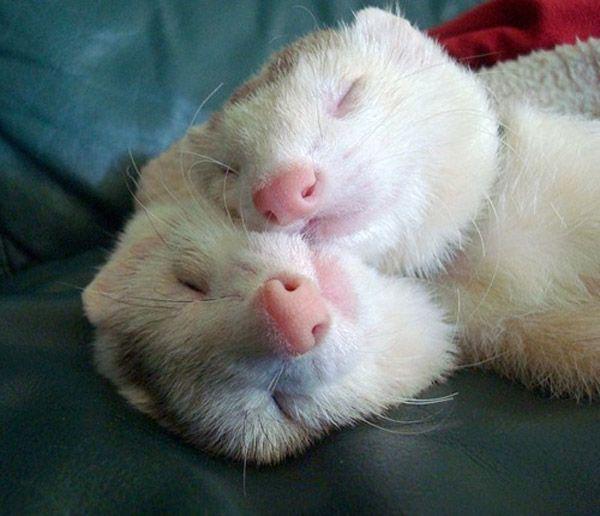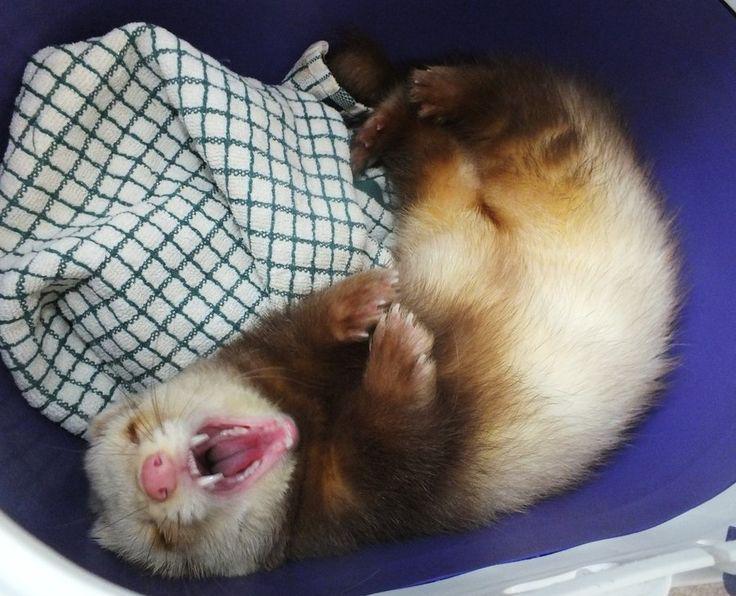The first image is the image on the left, the second image is the image on the right. For the images shown, is this caption "At least one image contains multiple ferrets, and at least one image includes a ferret in a resting pose." true? Answer yes or no. Yes. The first image is the image on the left, the second image is the image on the right. For the images displayed, is the sentence "At least one of the images has exactly one ferret." factually correct? Answer yes or no. Yes. 